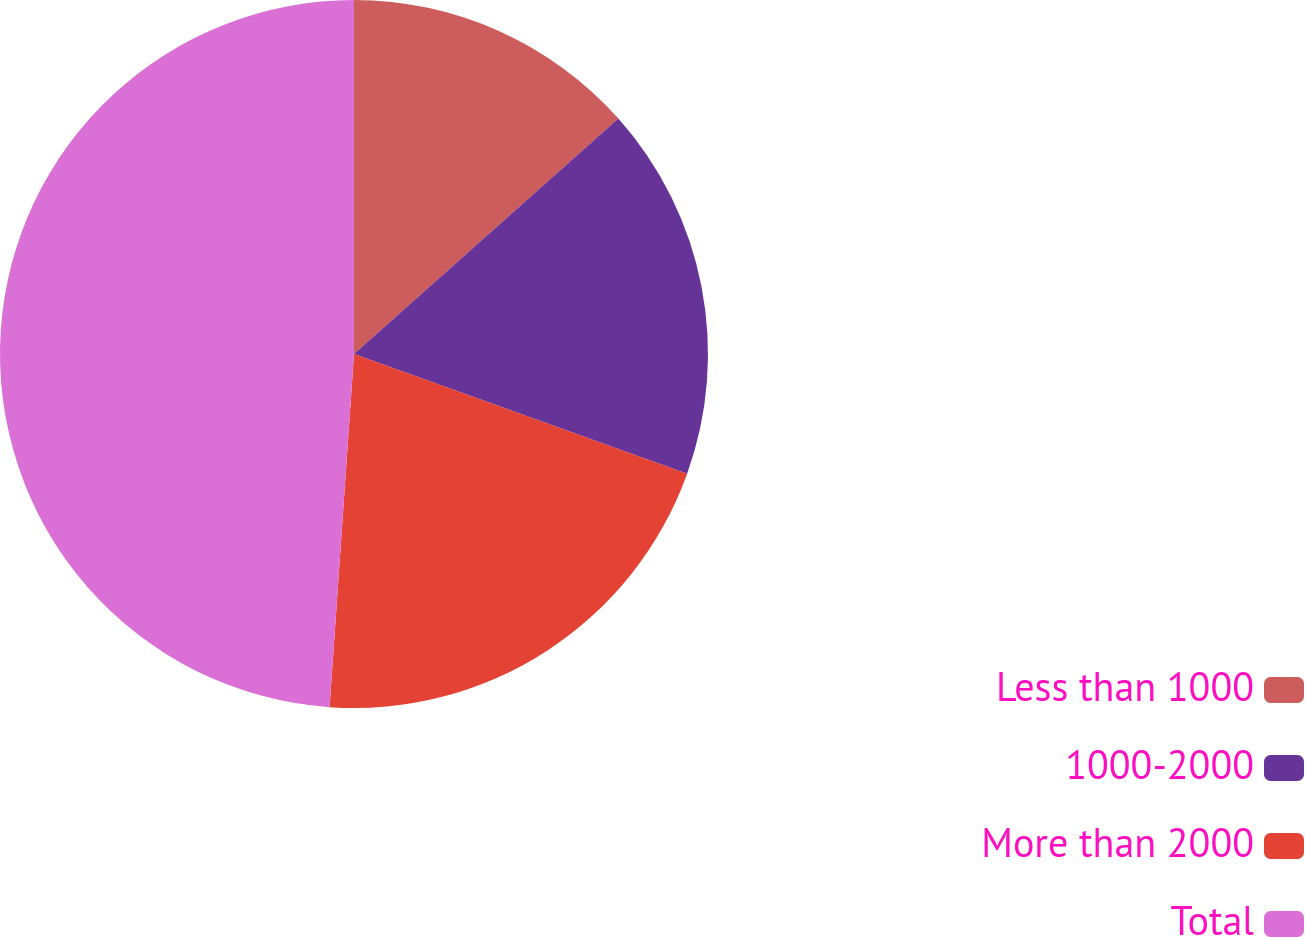Convert chart. <chart><loc_0><loc_0><loc_500><loc_500><pie_chart><fcel>Less than 1000<fcel>1000-2000<fcel>More than 2000<fcel>Total<nl><fcel>13.42%<fcel>17.07%<fcel>20.61%<fcel>48.9%<nl></chart> 